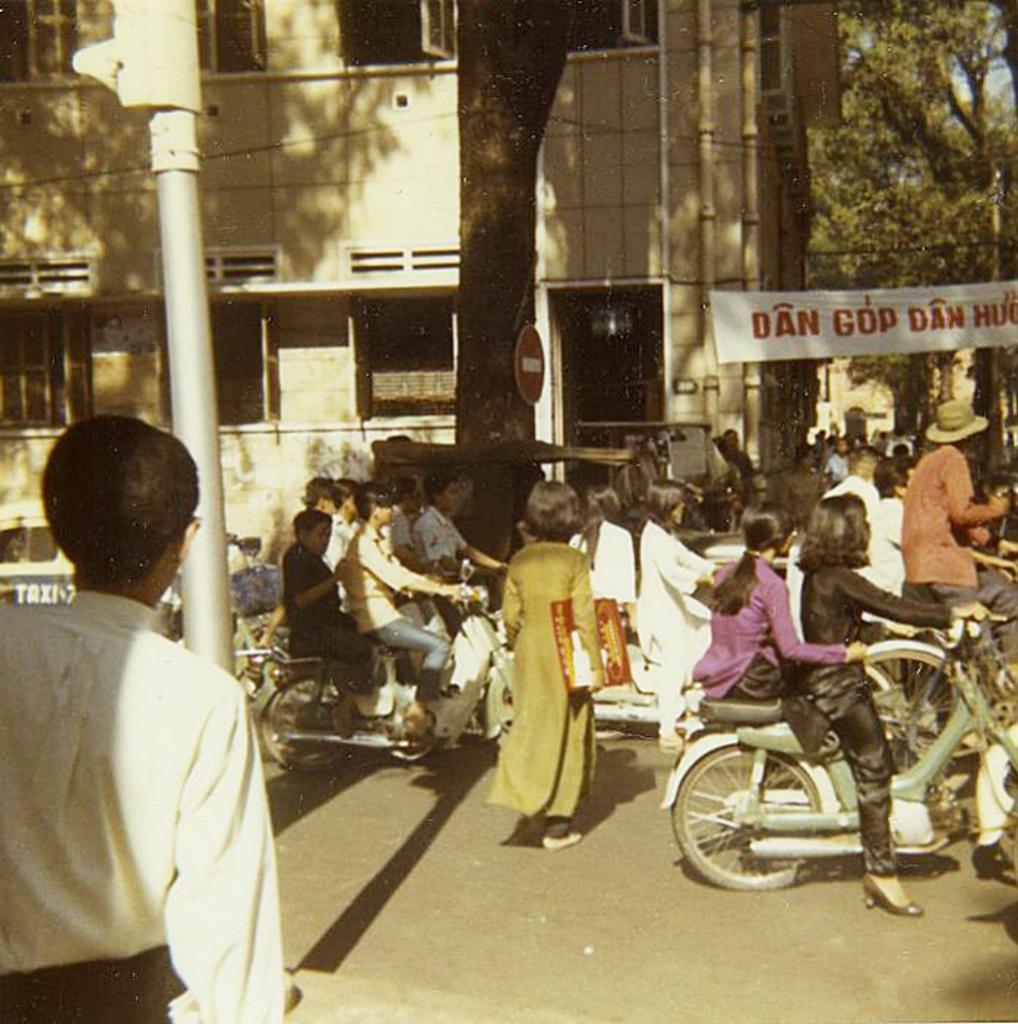How would you summarize this image in a sentence or two? In this picture I can see a group of people among them some are standing and some are sitting on the bikes. In the background I can see a banner on which something written on it. I can also see trees, a pole and other objects. 